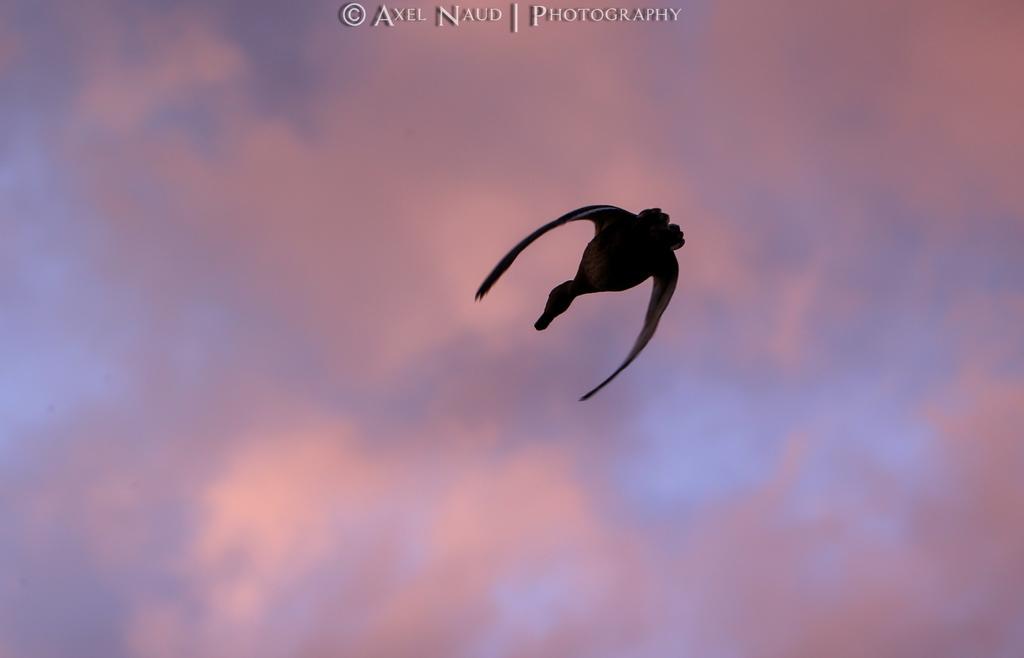Can you describe this image briefly? In this picture we can see a bird is flying in the air and behind the bird there is a cloudy sky and on the image there is a watermark. 